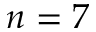Convert formula to latex. <formula><loc_0><loc_0><loc_500><loc_500>n = 7</formula> 